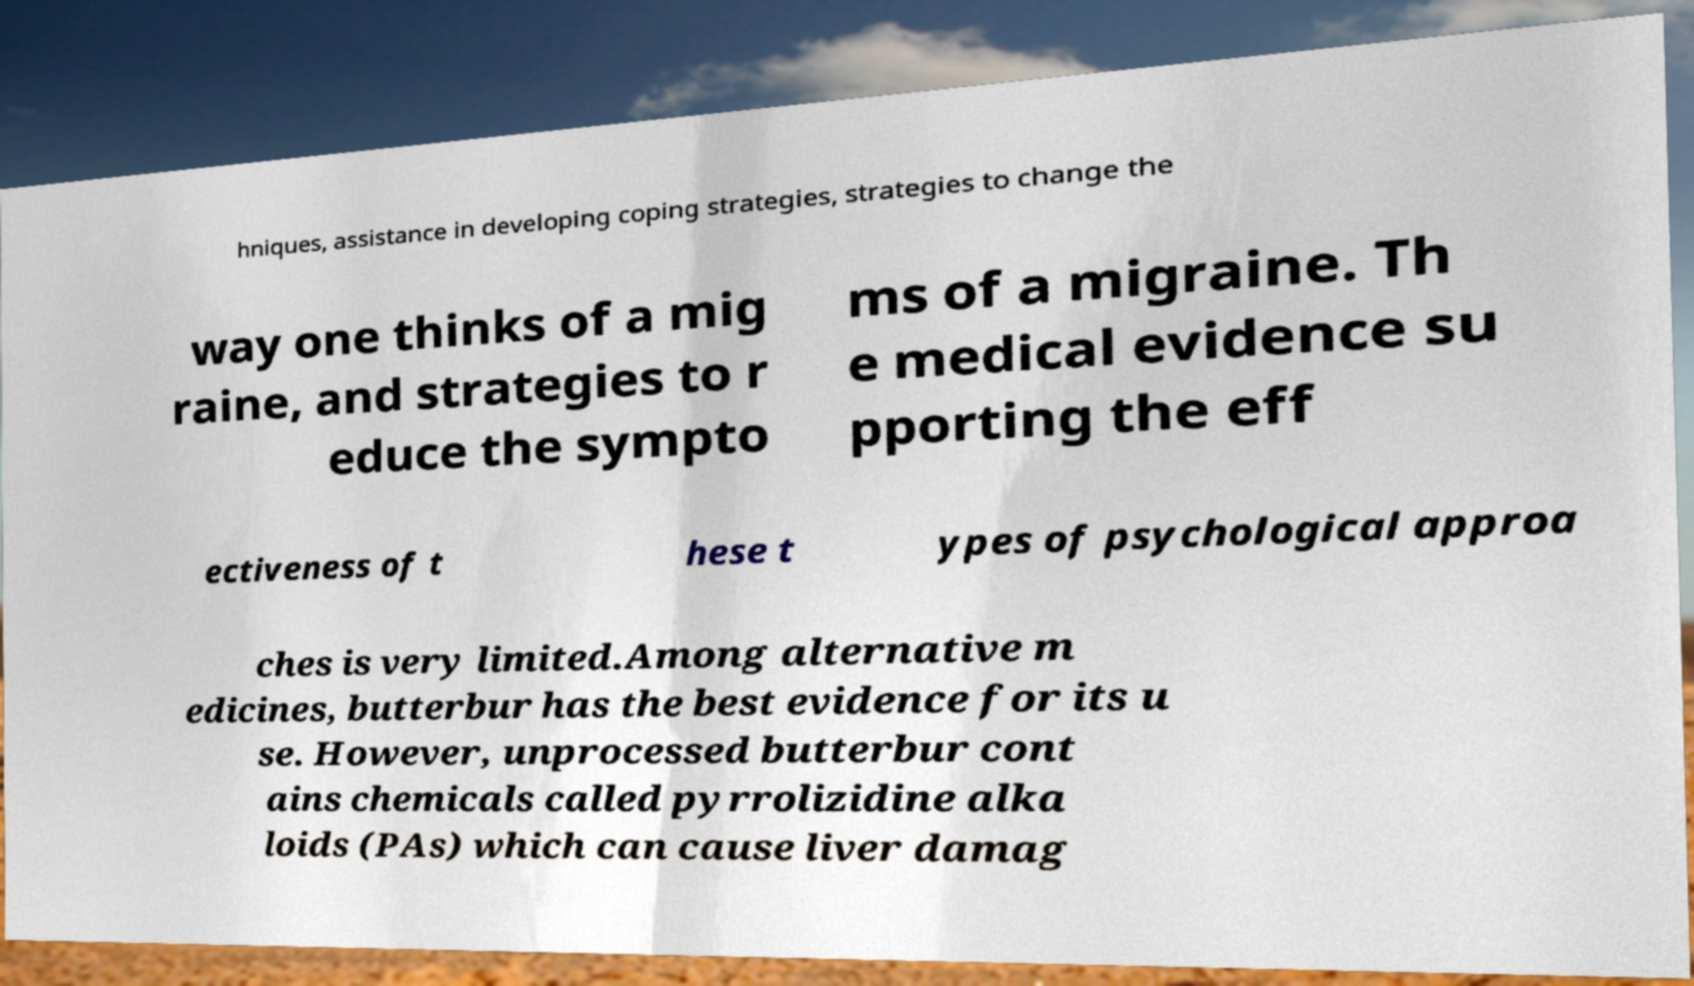Can you read and provide the text displayed in the image?This photo seems to have some interesting text. Can you extract and type it out for me? hniques, assistance in developing coping strategies, strategies to change the way one thinks of a mig raine, and strategies to r educe the sympto ms of a migraine. Th e medical evidence su pporting the eff ectiveness of t hese t ypes of psychological approa ches is very limited.Among alternative m edicines, butterbur has the best evidence for its u se. However, unprocessed butterbur cont ains chemicals called pyrrolizidine alka loids (PAs) which can cause liver damag 